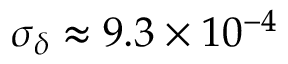<formula> <loc_0><loc_0><loc_500><loc_500>\sigma _ { \delta } \approx 9 . 3 \times 1 0 ^ { - 4 }</formula> 